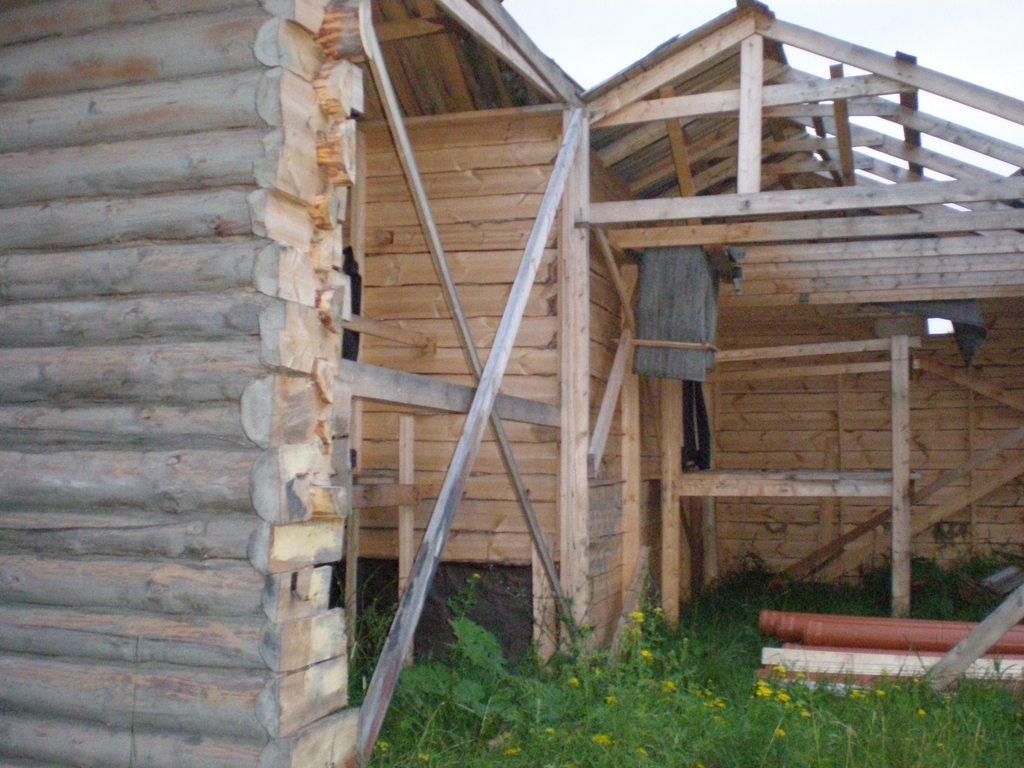What type of vegetation is present in the foreground of the image? There is grass in the foreground of the image. What structure can be seen under construction in the image? There is a wooden house under construction in the image. What is visible at the top of the image? The sky is visible at the top of the image. What type of cherry is being used as a representative in the image? There is no cherry present in the image, nor is there any representation of a cherry. 